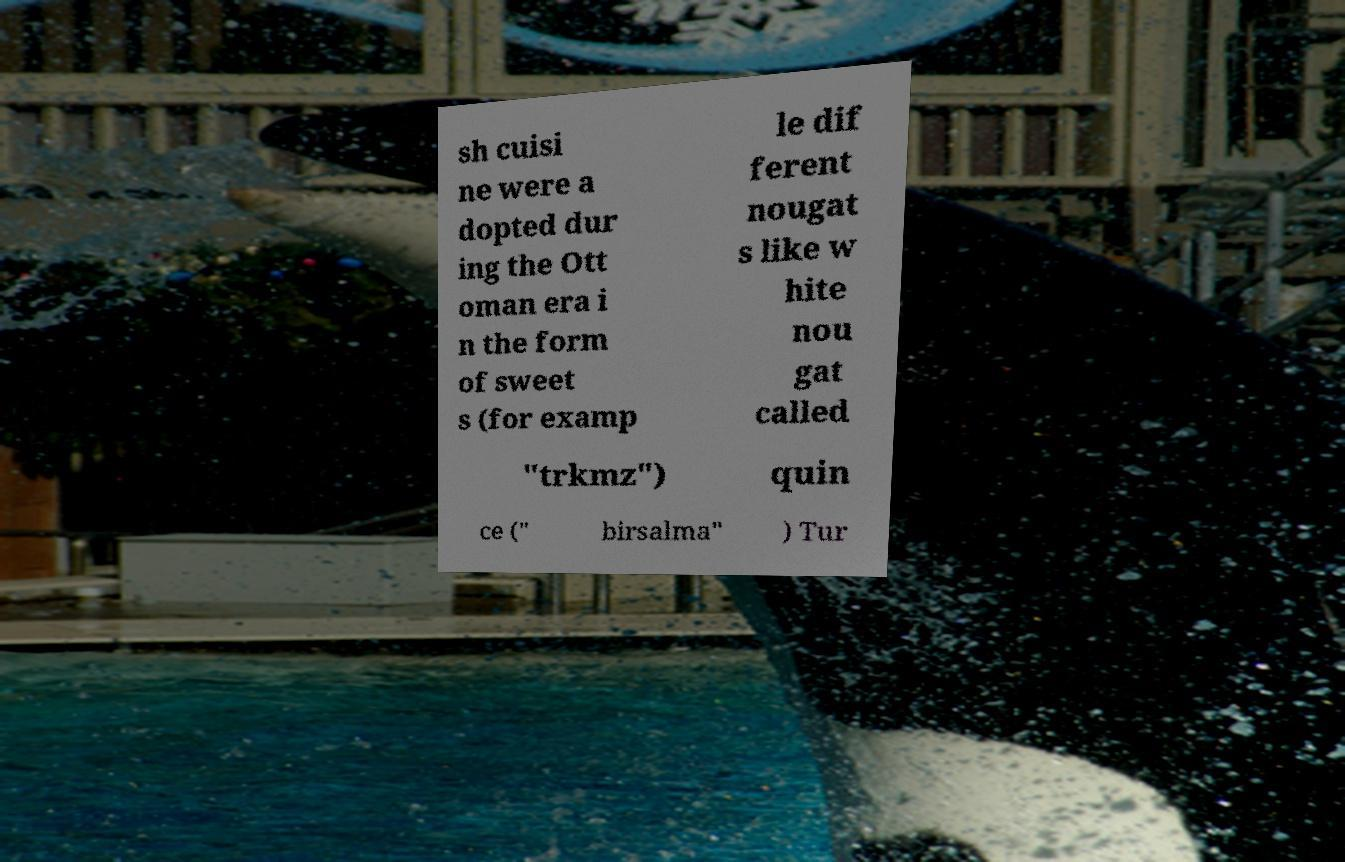Please read and relay the text visible in this image. What does it say? sh cuisi ne were a dopted dur ing the Ott oman era i n the form of sweet s (for examp le dif ferent nougat s like w hite nou gat called "trkmz") quin ce (" birsalma" ) Tur 